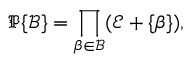<formula> <loc_0><loc_0><loc_500><loc_500>{ \mathfrak { P } } \{ { \mathcal { B } } \} = \prod _ { \beta \in { \mathcal { B } } } ( { \mathcal { E } } + \{ \beta \} ) ,</formula> 